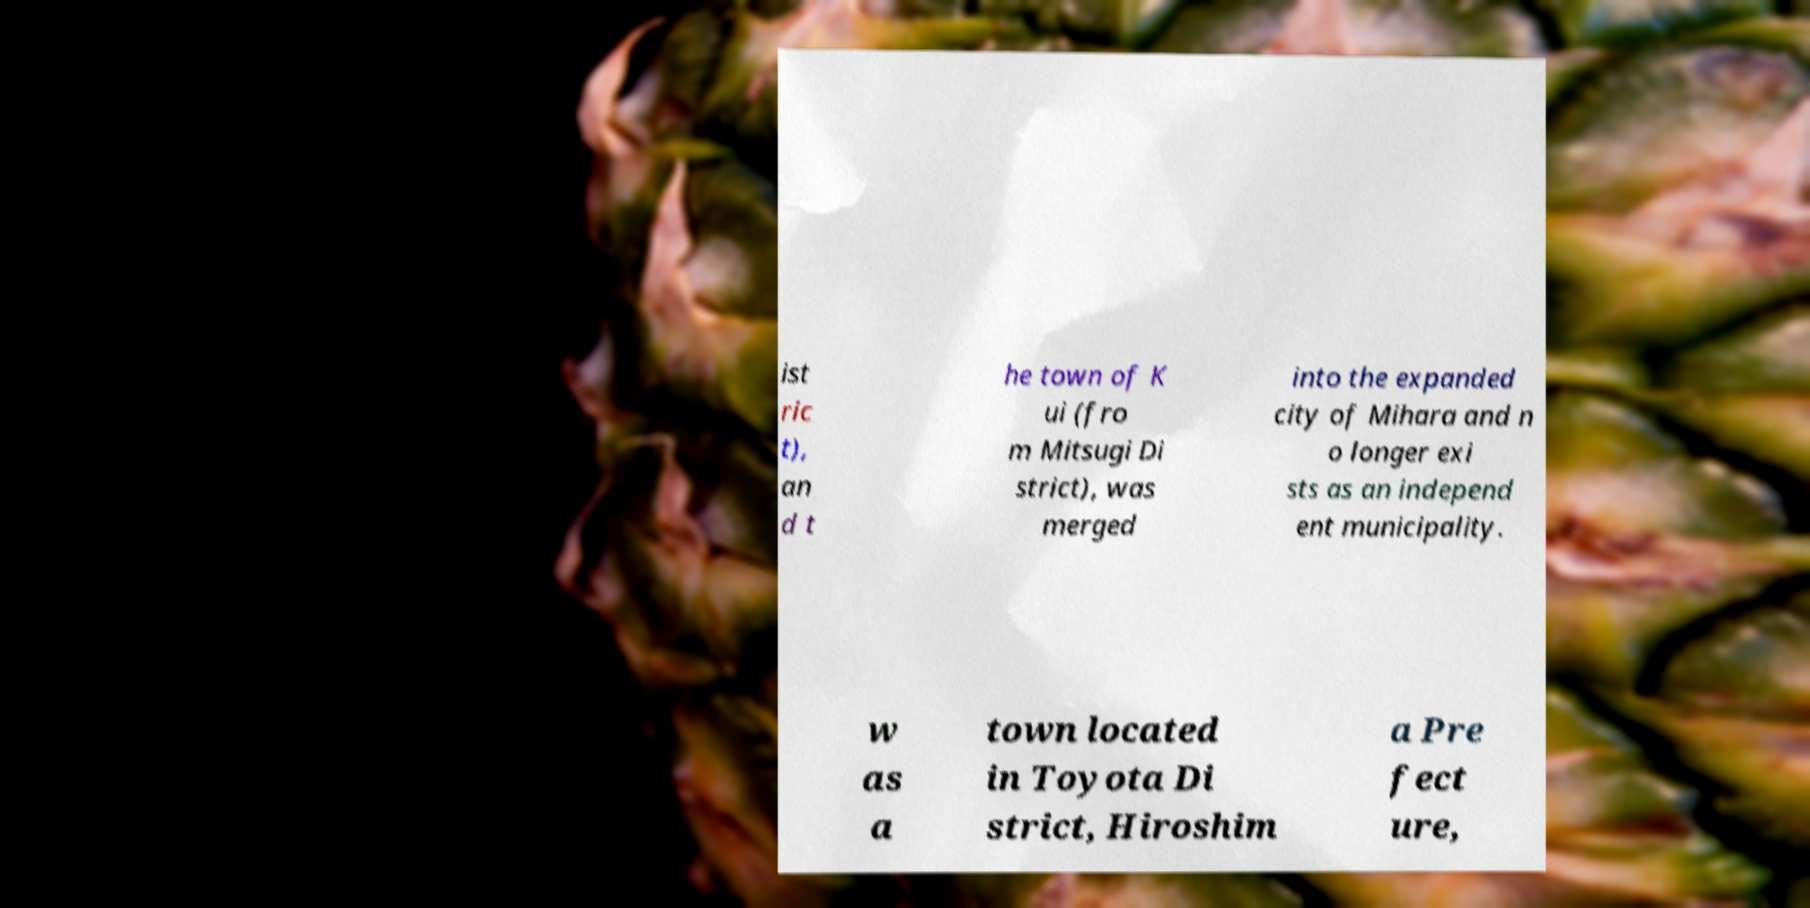Please read and relay the text visible in this image. What does it say? ist ric t), an d t he town of K ui (fro m Mitsugi Di strict), was merged into the expanded city of Mihara and n o longer exi sts as an independ ent municipality. w as a town located in Toyota Di strict, Hiroshim a Pre fect ure, 